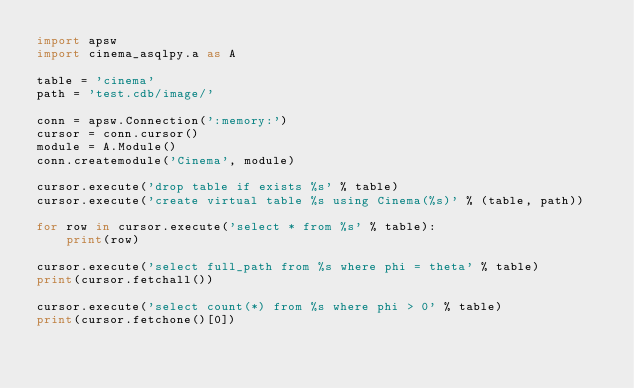<code> <loc_0><loc_0><loc_500><loc_500><_Python_>import apsw
import cinema_asqlpy.a as A

table = 'cinema'
path = 'test.cdb/image/'

conn = apsw.Connection(':memory:')
cursor = conn.cursor()
module = A.Module()
conn.createmodule('Cinema', module)

cursor.execute('drop table if exists %s' % table)
cursor.execute('create virtual table %s using Cinema(%s)' % (table, path))

for row in cursor.execute('select * from %s' % table):
    print(row)

cursor.execute('select full_path from %s where phi = theta' % table)
print(cursor.fetchall())

cursor.execute('select count(*) from %s where phi > 0' % table)
print(cursor.fetchone()[0])
</code> 